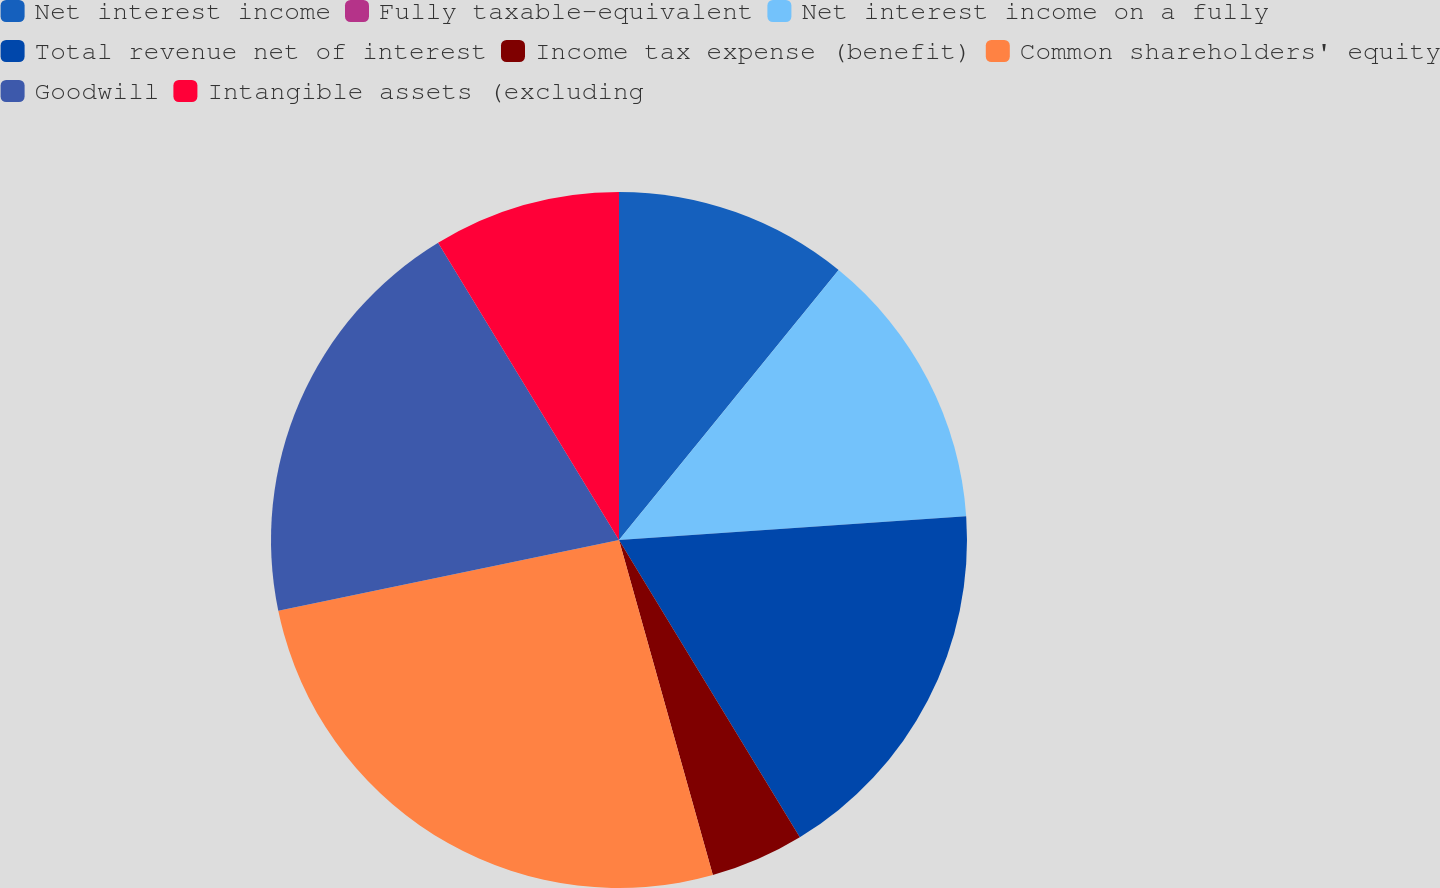Convert chart. <chart><loc_0><loc_0><loc_500><loc_500><pie_chart><fcel>Net interest income<fcel>Fully taxable-equivalent<fcel>Net interest income on a fully<fcel>Total revenue net of interest<fcel>Income tax expense (benefit)<fcel>Common shareholders' equity<fcel>Goodwill<fcel>Intangible assets (excluding<nl><fcel>10.87%<fcel>0.0%<fcel>13.04%<fcel>17.39%<fcel>4.35%<fcel>26.08%<fcel>19.56%<fcel>8.7%<nl></chart> 